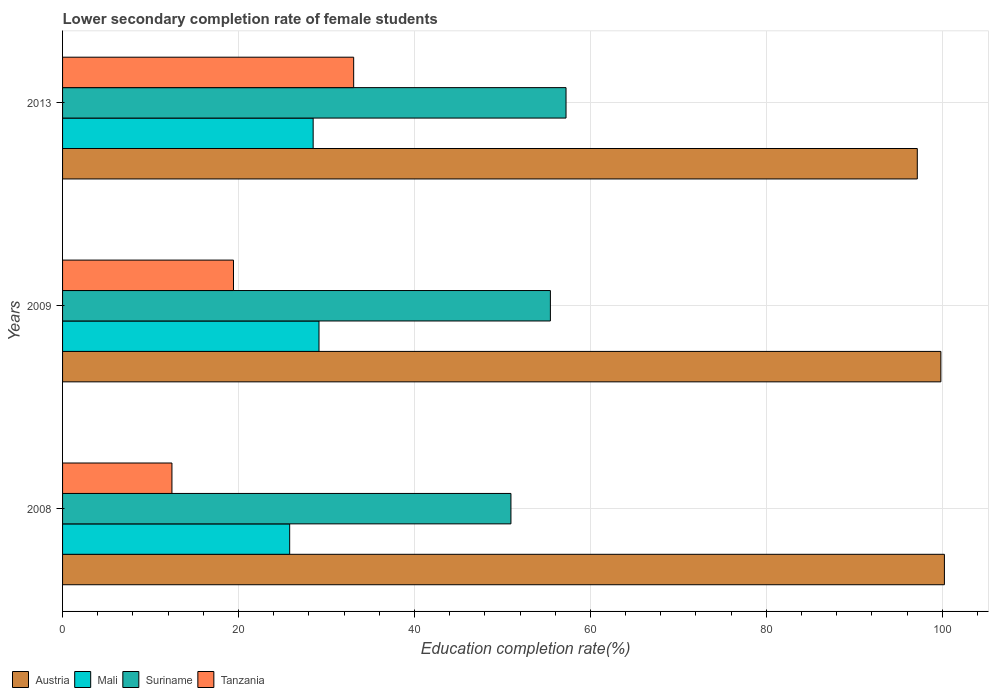How many bars are there on the 3rd tick from the top?
Ensure brevity in your answer.  4. What is the label of the 3rd group of bars from the top?
Give a very brief answer. 2008. In how many cases, is the number of bars for a given year not equal to the number of legend labels?
Offer a very short reply. 0. What is the lower secondary completion rate of female students in Tanzania in 2008?
Your response must be concise. 12.43. Across all years, what is the maximum lower secondary completion rate of female students in Suriname?
Give a very brief answer. 57.23. Across all years, what is the minimum lower secondary completion rate of female students in Tanzania?
Keep it short and to the point. 12.43. In which year was the lower secondary completion rate of female students in Mali maximum?
Provide a short and direct response. 2009. In which year was the lower secondary completion rate of female students in Tanzania minimum?
Make the answer very short. 2008. What is the total lower secondary completion rate of female students in Mali in the graph?
Your answer should be compact. 83.45. What is the difference between the lower secondary completion rate of female students in Tanzania in 2008 and that in 2013?
Provide a short and direct response. -20.66. What is the difference between the lower secondary completion rate of female students in Austria in 2008 and the lower secondary completion rate of female students in Suriname in 2013?
Your answer should be compact. 43.01. What is the average lower secondary completion rate of female students in Mali per year?
Your answer should be very brief. 27.82. In the year 2009, what is the difference between the lower secondary completion rate of female students in Austria and lower secondary completion rate of female students in Mali?
Provide a short and direct response. 70.69. What is the ratio of the lower secondary completion rate of female students in Austria in 2009 to that in 2013?
Offer a very short reply. 1.03. What is the difference between the highest and the second highest lower secondary completion rate of female students in Suriname?
Provide a succinct answer. 1.78. What is the difference between the highest and the lowest lower secondary completion rate of female students in Mali?
Your answer should be very brief. 3.33. In how many years, is the lower secondary completion rate of female students in Mali greater than the average lower secondary completion rate of female students in Mali taken over all years?
Provide a succinct answer. 2. Is the sum of the lower secondary completion rate of female students in Suriname in 2008 and 2009 greater than the maximum lower secondary completion rate of female students in Mali across all years?
Ensure brevity in your answer.  Yes. What does the 4th bar from the top in 2008 represents?
Offer a very short reply. Austria. What does the 2nd bar from the bottom in 2008 represents?
Your answer should be compact. Mali. Is it the case that in every year, the sum of the lower secondary completion rate of female students in Suriname and lower secondary completion rate of female students in Tanzania is greater than the lower secondary completion rate of female students in Austria?
Keep it short and to the point. No. How many bars are there?
Give a very brief answer. 12. How many years are there in the graph?
Make the answer very short. 3. What is the difference between two consecutive major ticks on the X-axis?
Your answer should be very brief. 20. Does the graph contain any zero values?
Provide a succinct answer. No. Does the graph contain grids?
Provide a succinct answer. Yes. How are the legend labels stacked?
Provide a succinct answer. Horizontal. What is the title of the graph?
Give a very brief answer. Lower secondary completion rate of female students. Does "Netherlands" appear as one of the legend labels in the graph?
Your answer should be compact. No. What is the label or title of the X-axis?
Ensure brevity in your answer.  Education completion rate(%). What is the Education completion rate(%) of Austria in 2008?
Your answer should be compact. 100.24. What is the Education completion rate(%) in Mali in 2008?
Provide a short and direct response. 25.82. What is the Education completion rate(%) of Suriname in 2008?
Offer a very short reply. 50.97. What is the Education completion rate(%) in Tanzania in 2008?
Make the answer very short. 12.43. What is the Education completion rate(%) in Austria in 2009?
Give a very brief answer. 99.84. What is the Education completion rate(%) of Mali in 2009?
Offer a very short reply. 29.15. What is the Education completion rate(%) in Suriname in 2009?
Offer a very short reply. 55.45. What is the Education completion rate(%) of Tanzania in 2009?
Ensure brevity in your answer.  19.43. What is the Education completion rate(%) of Austria in 2013?
Offer a terse response. 97.16. What is the Education completion rate(%) of Mali in 2013?
Keep it short and to the point. 28.48. What is the Education completion rate(%) in Suriname in 2013?
Your answer should be compact. 57.23. What is the Education completion rate(%) in Tanzania in 2013?
Give a very brief answer. 33.09. Across all years, what is the maximum Education completion rate(%) in Austria?
Offer a very short reply. 100.24. Across all years, what is the maximum Education completion rate(%) of Mali?
Offer a terse response. 29.15. Across all years, what is the maximum Education completion rate(%) of Suriname?
Your answer should be compact. 57.23. Across all years, what is the maximum Education completion rate(%) in Tanzania?
Offer a very short reply. 33.09. Across all years, what is the minimum Education completion rate(%) of Austria?
Keep it short and to the point. 97.16. Across all years, what is the minimum Education completion rate(%) of Mali?
Your answer should be compact. 25.82. Across all years, what is the minimum Education completion rate(%) of Suriname?
Your answer should be very brief. 50.97. Across all years, what is the minimum Education completion rate(%) in Tanzania?
Your answer should be compact. 12.43. What is the total Education completion rate(%) in Austria in the graph?
Your response must be concise. 297.23. What is the total Education completion rate(%) in Mali in the graph?
Your response must be concise. 83.45. What is the total Education completion rate(%) of Suriname in the graph?
Your response must be concise. 163.64. What is the total Education completion rate(%) of Tanzania in the graph?
Your answer should be compact. 64.95. What is the difference between the Education completion rate(%) of Austria in 2008 and that in 2009?
Offer a terse response. 0.4. What is the difference between the Education completion rate(%) of Mali in 2008 and that in 2009?
Your response must be concise. -3.33. What is the difference between the Education completion rate(%) of Suriname in 2008 and that in 2009?
Keep it short and to the point. -4.48. What is the difference between the Education completion rate(%) of Tanzania in 2008 and that in 2009?
Ensure brevity in your answer.  -7. What is the difference between the Education completion rate(%) in Austria in 2008 and that in 2013?
Keep it short and to the point. 3.08. What is the difference between the Education completion rate(%) in Mali in 2008 and that in 2013?
Keep it short and to the point. -2.67. What is the difference between the Education completion rate(%) in Suriname in 2008 and that in 2013?
Your answer should be compact. -6.26. What is the difference between the Education completion rate(%) in Tanzania in 2008 and that in 2013?
Keep it short and to the point. -20.66. What is the difference between the Education completion rate(%) of Austria in 2009 and that in 2013?
Keep it short and to the point. 2.68. What is the difference between the Education completion rate(%) in Mali in 2009 and that in 2013?
Your answer should be very brief. 0.66. What is the difference between the Education completion rate(%) in Suriname in 2009 and that in 2013?
Offer a terse response. -1.78. What is the difference between the Education completion rate(%) of Tanzania in 2009 and that in 2013?
Offer a very short reply. -13.66. What is the difference between the Education completion rate(%) of Austria in 2008 and the Education completion rate(%) of Mali in 2009?
Offer a terse response. 71.09. What is the difference between the Education completion rate(%) of Austria in 2008 and the Education completion rate(%) of Suriname in 2009?
Your response must be concise. 44.79. What is the difference between the Education completion rate(%) of Austria in 2008 and the Education completion rate(%) of Tanzania in 2009?
Make the answer very short. 80.81. What is the difference between the Education completion rate(%) in Mali in 2008 and the Education completion rate(%) in Suriname in 2009?
Provide a short and direct response. -29.64. What is the difference between the Education completion rate(%) of Mali in 2008 and the Education completion rate(%) of Tanzania in 2009?
Keep it short and to the point. 6.39. What is the difference between the Education completion rate(%) of Suriname in 2008 and the Education completion rate(%) of Tanzania in 2009?
Your answer should be compact. 31.54. What is the difference between the Education completion rate(%) of Austria in 2008 and the Education completion rate(%) of Mali in 2013?
Your answer should be very brief. 71.75. What is the difference between the Education completion rate(%) in Austria in 2008 and the Education completion rate(%) in Suriname in 2013?
Give a very brief answer. 43.01. What is the difference between the Education completion rate(%) of Austria in 2008 and the Education completion rate(%) of Tanzania in 2013?
Your response must be concise. 67.15. What is the difference between the Education completion rate(%) of Mali in 2008 and the Education completion rate(%) of Suriname in 2013?
Offer a very short reply. -31.41. What is the difference between the Education completion rate(%) of Mali in 2008 and the Education completion rate(%) of Tanzania in 2013?
Ensure brevity in your answer.  -7.27. What is the difference between the Education completion rate(%) in Suriname in 2008 and the Education completion rate(%) in Tanzania in 2013?
Ensure brevity in your answer.  17.88. What is the difference between the Education completion rate(%) in Austria in 2009 and the Education completion rate(%) in Mali in 2013?
Provide a short and direct response. 71.35. What is the difference between the Education completion rate(%) in Austria in 2009 and the Education completion rate(%) in Suriname in 2013?
Offer a very short reply. 42.61. What is the difference between the Education completion rate(%) of Austria in 2009 and the Education completion rate(%) of Tanzania in 2013?
Offer a terse response. 66.75. What is the difference between the Education completion rate(%) of Mali in 2009 and the Education completion rate(%) of Suriname in 2013?
Your answer should be very brief. -28.08. What is the difference between the Education completion rate(%) of Mali in 2009 and the Education completion rate(%) of Tanzania in 2013?
Give a very brief answer. -3.94. What is the difference between the Education completion rate(%) in Suriname in 2009 and the Education completion rate(%) in Tanzania in 2013?
Your answer should be compact. 22.36. What is the average Education completion rate(%) in Austria per year?
Give a very brief answer. 99.08. What is the average Education completion rate(%) in Mali per year?
Ensure brevity in your answer.  27.82. What is the average Education completion rate(%) in Suriname per year?
Your response must be concise. 54.55. What is the average Education completion rate(%) of Tanzania per year?
Keep it short and to the point. 21.65. In the year 2008, what is the difference between the Education completion rate(%) in Austria and Education completion rate(%) in Mali?
Your answer should be compact. 74.42. In the year 2008, what is the difference between the Education completion rate(%) in Austria and Education completion rate(%) in Suriname?
Offer a terse response. 49.27. In the year 2008, what is the difference between the Education completion rate(%) in Austria and Education completion rate(%) in Tanzania?
Ensure brevity in your answer.  87.8. In the year 2008, what is the difference between the Education completion rate(%) of Mali and Education completion rate(%) of Suriname?
Your answer should be compact. -25.15. In the year 2008, what is the difference between the Education completion rate(%) in Mali and Education completion rate(%) in Tanzania?
Give a very brief answer. 13.38. In the year 2008, what is the difference between the Education completion rate(%) in Suriname and Education completion rate(%) in Tanzania?
Your answer should be compact. 38.53. In the year 2009, what is the difference between the Education completion rate(%) of Austria and Education completion rate(%) of Mali?
Keep it short and to the point. 70.69. In the year 2009, what is the difference between the Education completion rate(%) of Austria and Education completion rate(%) of Suriname?
Give a very brief answer. 44.39. In the year 2009, what is the difference between the Education completion rate(%) in Austria and Education completion rate(%) in Tanzania?
Offer a very short reply. 80.41. In the year 2009, what is the difference between the Education completion rate(%) of Mali and Education completion rate(%) of Suriname?
Your answer should be very brief. -26.3. In the year 2009, what is the difference between the Education completion rate(%) of Mali and Education completion rate(%) of Tanzania?
Offer a terse response. 9.72. In the year 2009, what is the difference between the Education completion rate(%) in Suriname and Education completion rate(%) in Tanzania?
Make the answer very short. 36.02. In the year 2013, what is the difference between the Education completion rate(%) of Austria and Education completion rate(%) of Mali?
Your answer should be compact. 68.67. In the year 2013, what is the difference between the Education completion rate(%) of Austria and Education completion rate(%) of Suriname?
Offer a very short reply. 39.93. In the year 2013, what is the difference between the Education completion rate(%) of Austria and Education completion rate(%) of Tanzania?
Give a very brief answer. 64.07. In the year 2013, what is the difference between the Education completion rate(%) of Mali and Education completion rate(%) of Suriname?
Your answer should be very brief. -28.74. In the year 2013, what is the difference between the Education completion rate(%) of Mali and Education completion rate(%) of Tanzania?
Offer a very short reply. -4.61. In the year 2013, what is the difference between the Education completion rate(%) of Suriname and Education completion rate(%) of Tanzania?
Your answer should be compact. 24.14. What is the ratio of the Education completion rate(%) in Austria in 2008 to that in 2009?
Provide a succinct answer. 1. What is the ratio of the Education completion rate(%) of Mali in 2008 to that in 2009?
Keep it short and to the point. 0.89. What is the ratio of the Education completion rate(%) of Suriname in 2008 to that in 2009?
Your response must be concise. 0.92. What is the ratio of the Education completion rate(%) of Tanzania in 2008 to that in 2009?
Your response must be concise. 0.64. What is the ratio of the Education completion rate(%) of Austria in 2008 to that in 2013?
Offer a very short reply. 1.03. What is the ratio of the Education completion rate(%) of Mali in 2008 to that in 2013?
Offer a very short reply. 0.91. What is the ratio of the Education completion rate(%) in Suriname in 2008 to that in 2013?
Make the answer very short. 0.89. What is the ratio of the Education completion rate(%) in Tanzania in 2008 to that in 2013?
Offer a terse response. 0.38. What is the ratio of the Education completion rate(%) of Austria in 2009 to that in 2013?
Give a very brief answer. 1.03. What is the ratio of the Education completion rate(%) of Mali in 2009 to that in 2013?
Keep it short and to the point. 1.02. What is the ratio of the Education completion rate(%) of Suriname in 2009 to that in 2013?
Provide a succinct answer. 0.97. What is the ratio of the Education completion rate(%) of Tanzania in 2009 to that in 2013?
Keep it short and to the point. 0.59. What is the difference between the highest and the second highest Education completion rate(%) of Austria?
Provide a succinct answer. 0.4. What is the difference between the highest and the second highest Education completion rate(%) of Mali?
Ensure brevity in your answer.  0.66. What is the difference between the highest and the second highest Education completion rate(%) in Suriname?
Provide a succinct answer. 1.78. What is the difference between the highest and the second highest Education completion rate(%) of Tanzania?
Offer a very short reply. 13.66. What is the difference between the highest and the lowest Education completion rate(%) in Austria?
Your answer should be very brief. 3.08. What is the difference between the highest and the lowest Education completion rate(%) in Mali?
Your answer should be very brief. 3.33. What is the difference between the highest and the lowest Education completion rate(%) of Suriname?
Give a very brief answer. 6.26. What is the difference between the highest and the lowest Education completion rate(%) in Tanzania?
Provide a succinct answer. 20.66. 